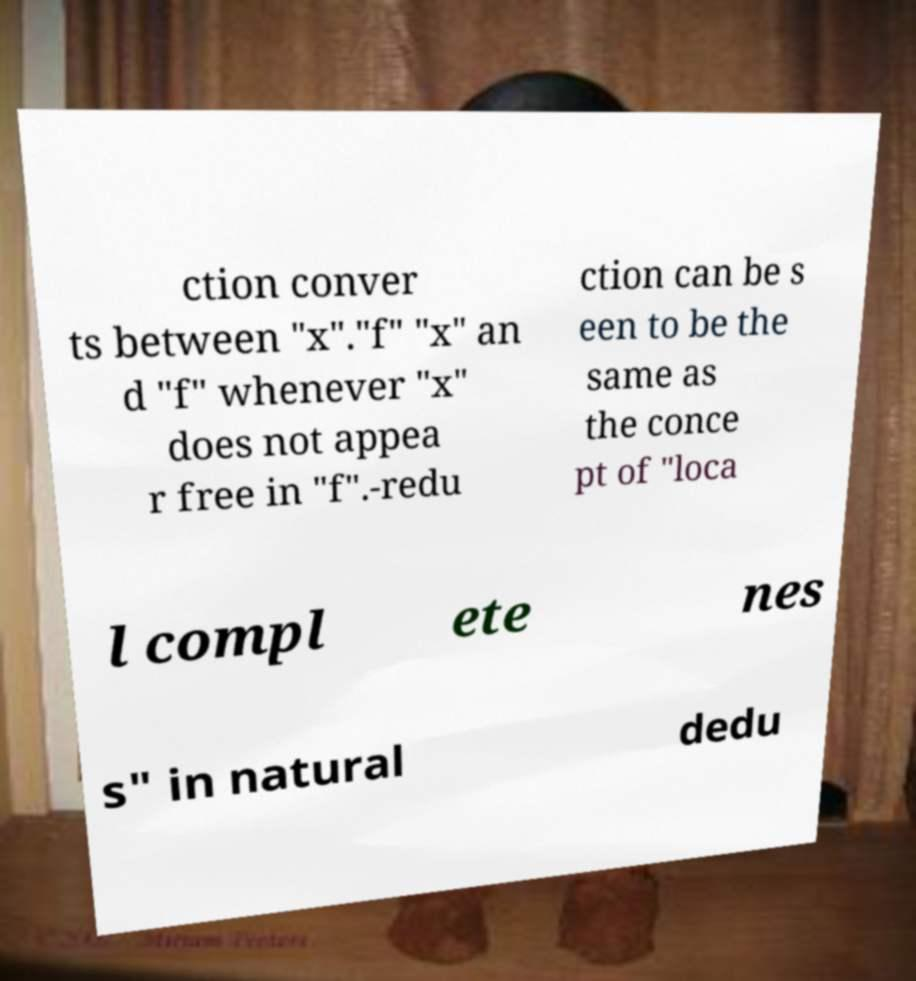Please identify and transcribe the text found in this image. ction conver ts between "x"."f" "x" an d "f" whenever "x" does not appea r free in "f".-redu ction can be s een to be the same as the conce pt of "loca l compl ete nes s" in natural dedu 